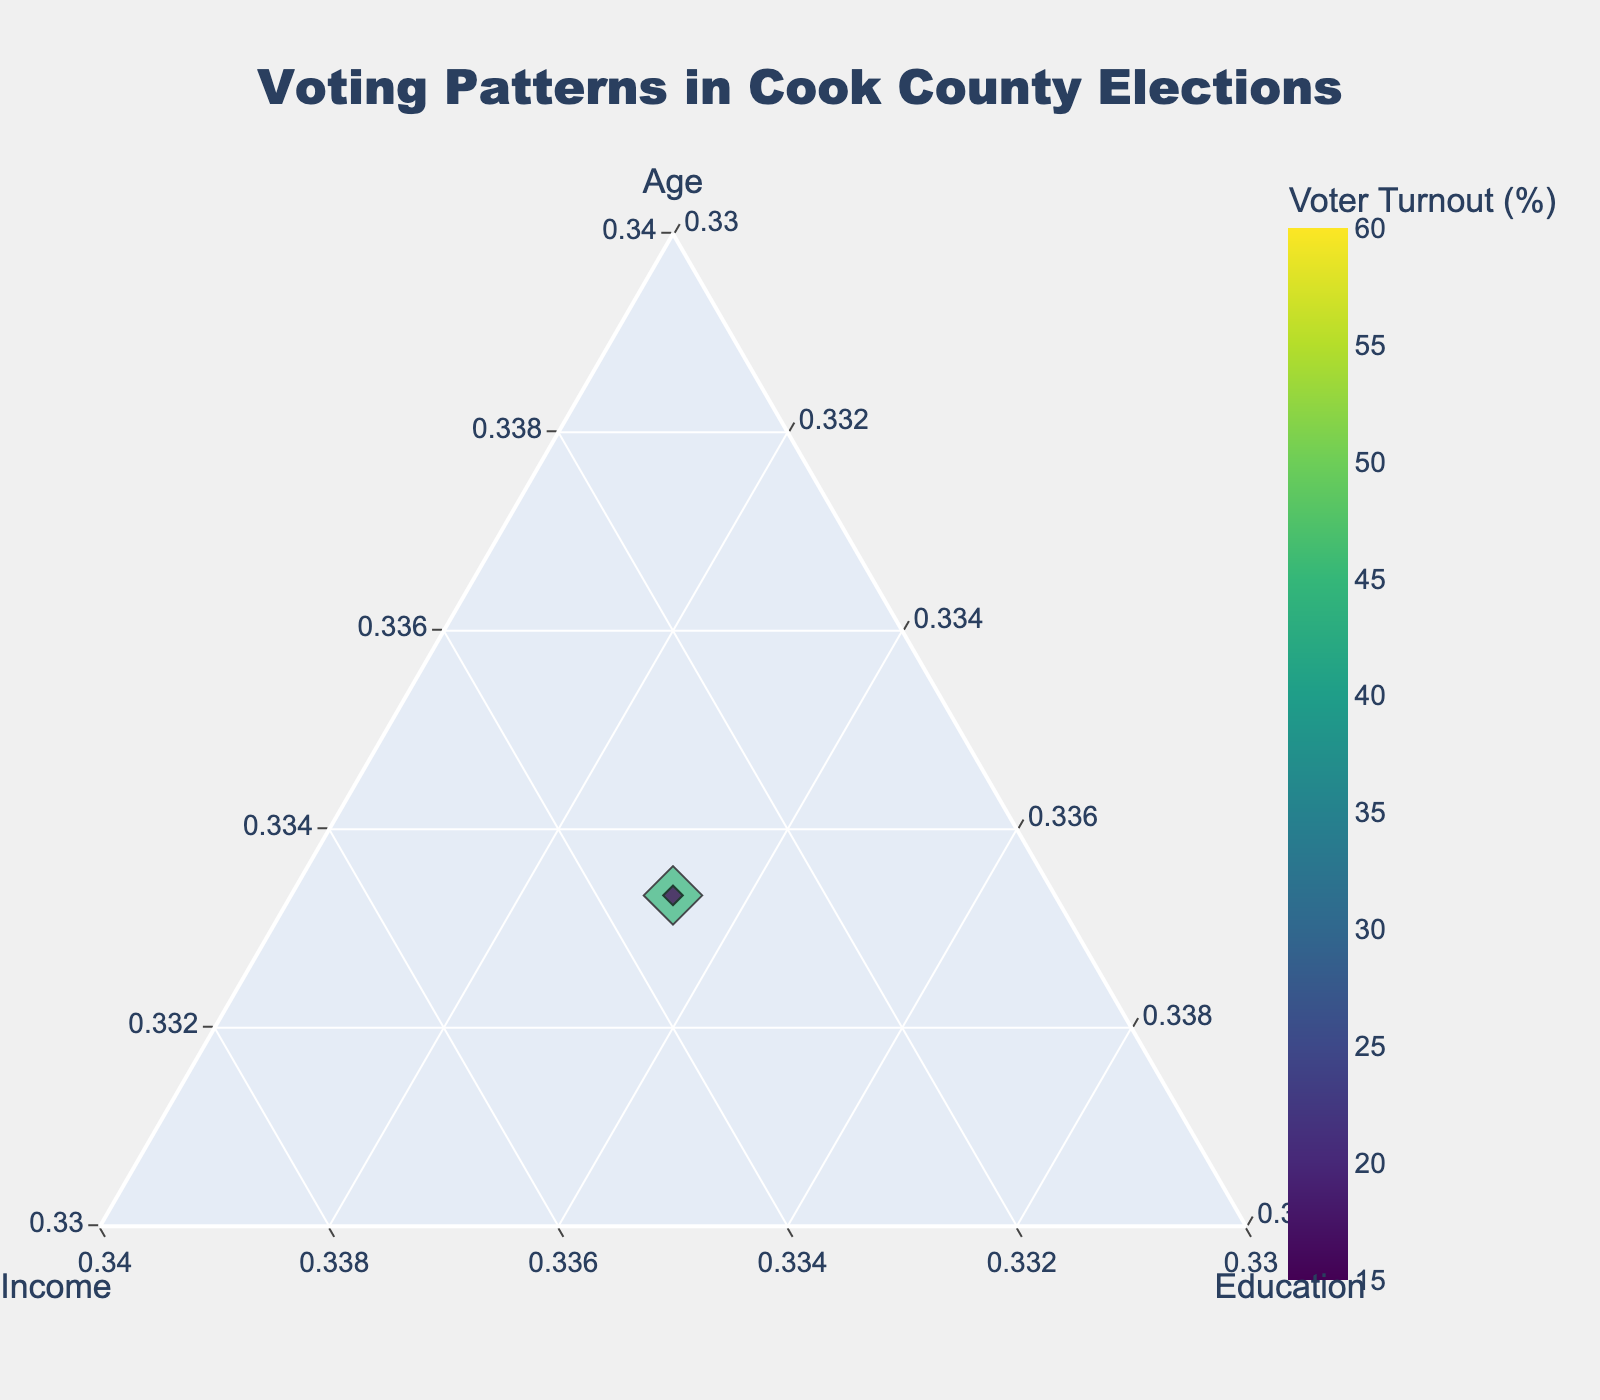What is the title of the plot? The title is located at the top center of the plot. It is written in a bold font size, making it easily noticeable.
Answer: Voting Patterns in Cook County Elections What are the three axes in the ternary plot labeled as? The plot has three axes that form a triangle, each labeled at the edge of the triangle. The labels represent the variables being studied.
Answer: Age, Income, Education How is the voter turnout represented in the plot? The voter turnout is represented by the color and size of the markers. Higher voter turnout corresponds to larger and darker-colored markers. The color scale is displayed on the side of the plot.
Answer: Color and size of the markers Which age group has the highest voter turnout according to the plot? Look for the largest and darkest markers in the plot corresponding to the different age groups. The hover text can also provide this information.
Answer: Senior Is there a relationship between income level and voter turnout? Observing the colors and sizes of the markers along the Income axis can give insights into any patterns. Compare the voter turnout between low, medium, and high-income levels.
Answer: Generally, higher income correlates with higher voter turnout What is the voter turnout for young individuals with high education and low income? Hover over the marker representing young individuals with high education and low income to see the hover text displaying the voter turnout.
Answer: 25% How does the voter turnout for middle-aged individuals with medium income and medium education compare to that of seniors with medium income and high education? Identify and compare the markers for both groups. Middle-aged with medium income and education has a voter turnout of 45%, while seniors with medium income and high education have 60%.
Answer: 45% vs 60% Which group has the lowest voter turnout, and what are their characteristics? Look for the smallest and lightest-colored marker on the plot and check the hover text for its details.
Answer: Young, low income, low education What is the average voter turnout for middle-aged individuals? Identify all points corresponding to middle-aged individuals and calculate the average of their voter turnout values. (35% + 45% + 40% + 30% + 50%) / 5 = 40%
Answer: 40% Which factor (age, income, or education) seems to have the most influence on voter turnout? Consider which axis's markers show the most variation in color and size. Cross-reference with known details on voter groups.
Answer: Age seems to have the most influence 